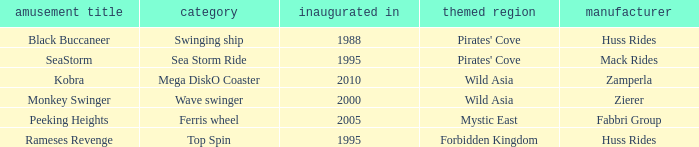What type ride is Wild Asia that opened in 2000? Wave swinger. Would you mind parsing the complete table? {'header': ['amusement title', 'category', 'inaugurated in', 'themed region', 'manufacturer'], 'rows': [['Black Buccaneer', 'Swinging ship', '1988', "Pirates' Cove", 'Huss Rides'], ['SeaStorm', 'Sea Storm Ride', '1995', "Pirates' Cove", 'Mack Rides'], ['Kobra', 'Mega DiskO Coaster', '2010', 'Wild Asia', 'Zamperla'], ['Monkey Swinger', 'Wave swinger', '2000', 'Wild Asia', 'Zierer'], ['Peeking Heights', 'Ferris wheel', '2005', 'Mystic East', 'Fabbri Group'], ['Rameses Revenge', 'Top Spin', '1995', 'Forbidden Kingdom', 'Huss Rides']]} 